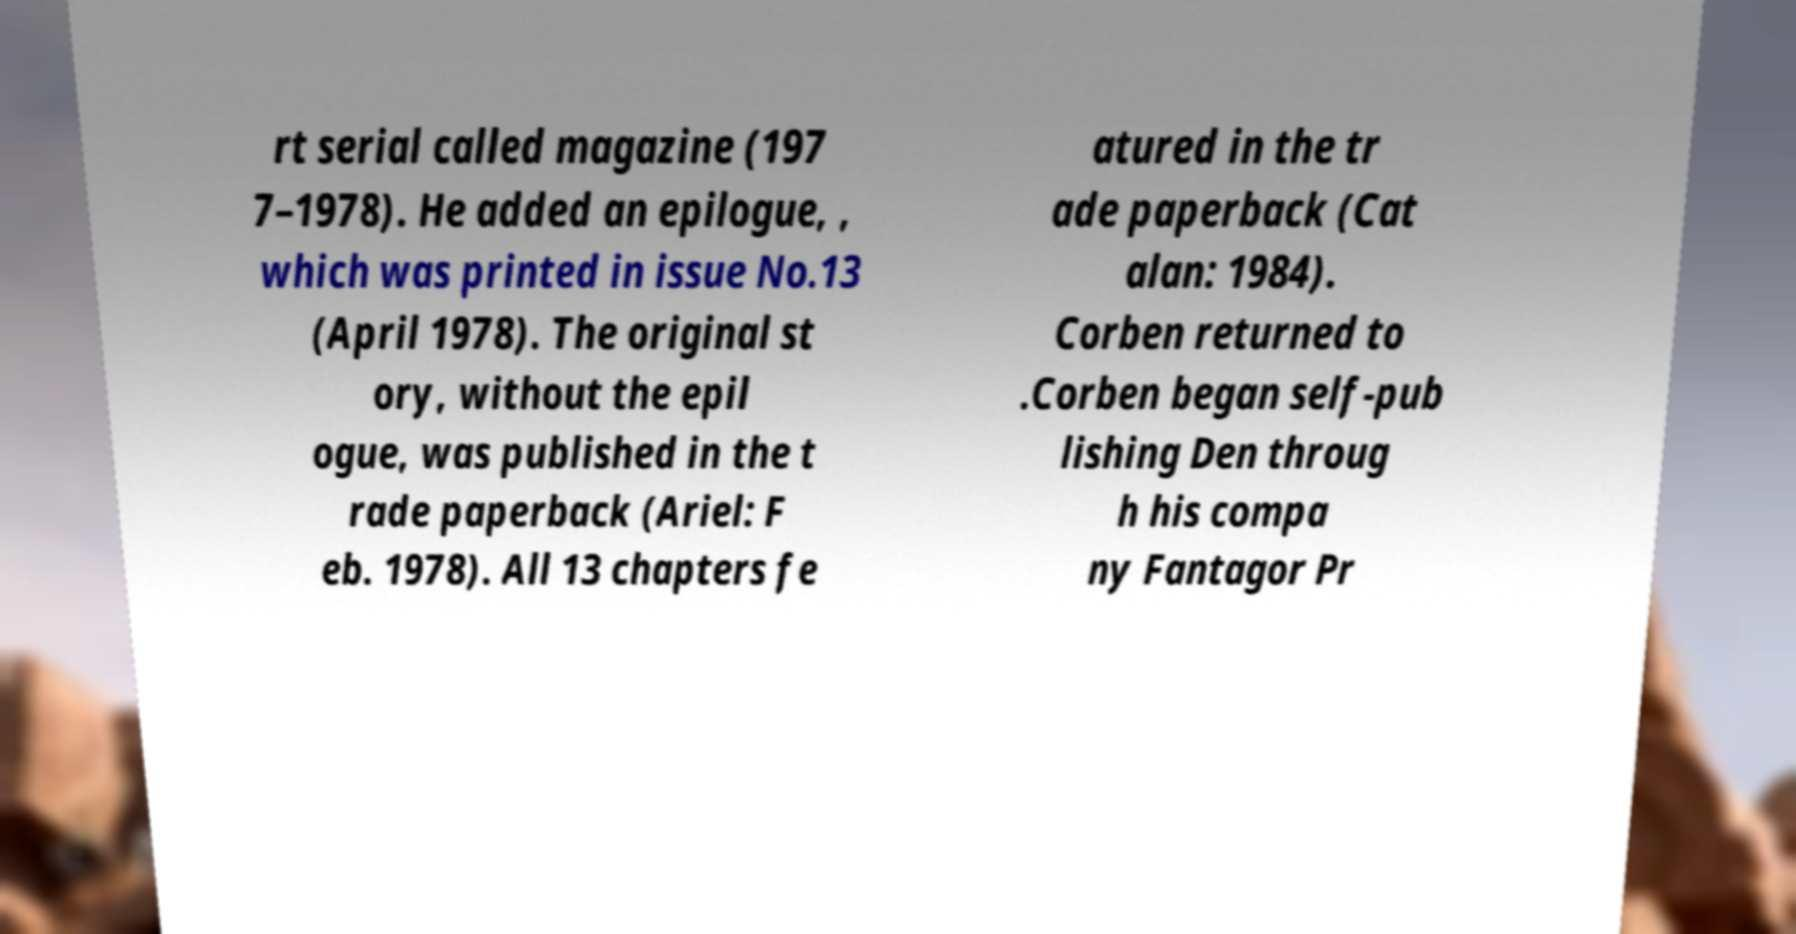Could you extract and type out the text from this image? rt serial called magazine (197 7–1978). He added an epilogue, , which was printed in issue No.13 (April 1978). The original st ory, without the epil ogue, was published in the t rade paperback (Ariel: F eb. 1978). All 13 chapters fe atured in the tr ade paperback (Cat alan: 1984). Corben returned to .Corben began self-pub lishing Den throug h his compa ny Fantagor Pr 